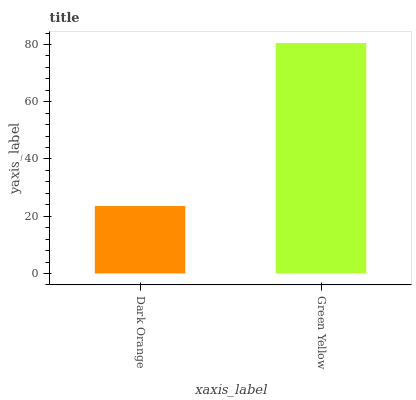Is Dark Orange the minimum?
Answer yes or no. Yes. Is Green Yellow the maximum?
Answer yes or no. Yes. Is Green Yellow the minimum?
Answer yes or no. No. Is Green Yellow greater than Dark Orange?
Answer yes or no. Yes. Is Dark Orange less than Green Yellow?
Answer yes or no. Yes. Is Dark Orange greater than Green Yellow?
Answer yes or no. No. Is Green Yellow less than Dark Orange?
Answer yes or no. No. Is Green Yellow the high median?
Answer yes or no. Yes. Is Dark Orange the low median?
Answer yes or no. Yes. Is Dark Orange the high median?
Answer yes or no. No. Is Green Yellow the low median?
Answer yes or no. No. 